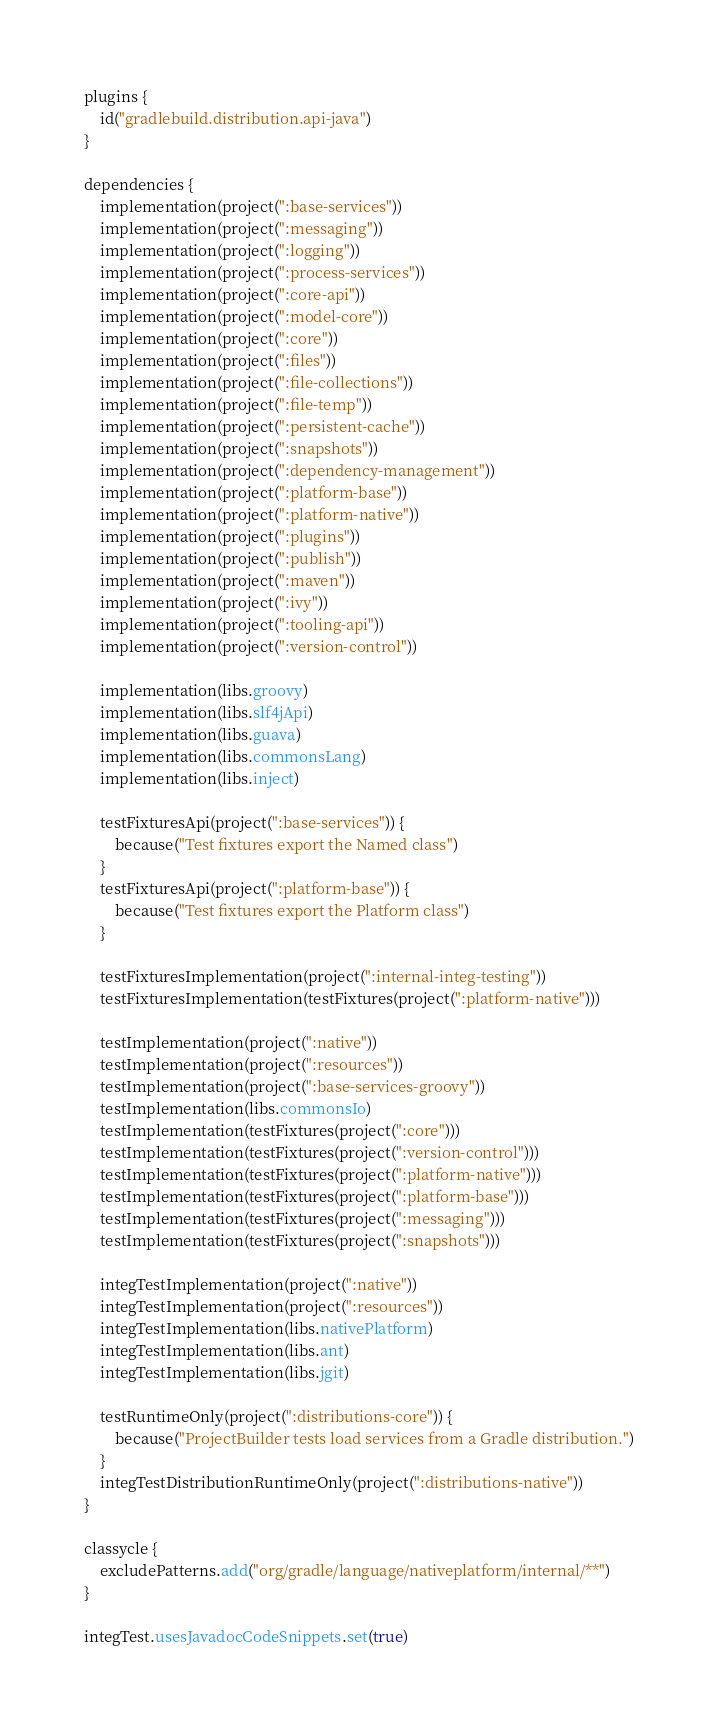<code> <loc_0><loc_0><loc_500><loc_500><_Kotlin_>plugins {
    id("gradlebuild.distribution.api-java")
}

dependencies {
    implementation(project(":base-services"))
    implementation(project(":messaging"))
    implementation(project(":logging"))
    implementation(project(":process-services"))
    implementation(project(":core-api"))
    implementation(project(":model-core"))
    implementation(project(":core"))
    implementation(project(":files"))
    implementation(project(":file-collections"))
    implementation(project(":file-temp"))
    implementation(project(":persistent-cache"))
    implementation(project(":snapshots"))
    implementation(project(":dependency-management"))
    implementation(project(":platform-base"))
    implementation(project(":platform-native"))
    implementation(project(":plugins"))
    implementation(project(":publish"))
    implementation(project(":maven"))
    implementation(project(":ivy"))
    implementation(project(":tooling-api"))
    implementation(project(":version-control"))

    implementation(libs.groovy)
    implementation(libs.slf4jApi)
    implementation(libs.guava)
    implementation(libs.commonsLang)
    implementation(libs.inject)

    testFixturesApi(project(":base-services")) {
        because("Test fixtures export the Named class")
    }
    testFixturesApi(project(":platform-base")) {
        because("Test fixtures export the Platform class")
    }

    testFixturesImplementation(project(":internal-integ-testing"))
    testFixturesImplementation(testFixtures(project(":platform-native")))

    testImplementation(project(":native"))
    testImplementation(project(":resources"))
    testImplementation(project(":base-services-groovy"))
    testImplementation(libs.commonsIo)
    testImplementation(testFixtures(project(":core")))
    testImplementation(testFixtures(project(":version-control")))
    testImplementation(testFixtures(project(":platform-native")))
    testImplementation(testFixtures(project(":platform-base")))
    testImplementation(testFixtures(project(":messaging")))
    testImplementation(testFixtures(project(":snapshots")))

    integTestImplementation(project(":native"))
    integTestImplementation(project(":resources"))
    integTestImplementation(libs.nativePlatform)
    integTestImplementation(libs.ant)
    integTestImplementation(libs.jgit)

    testRuntimeOnly(project(":distributions-core")) {
        because("ProjectBuilder tests load services from a Gradle distribution.")
    }
    integTestDistributionRuntimeOnly(project(":distributions-native"))
}

classycle {
    excludePatterns.add("org/gradle/language/nativeplatform/internal/**")
}

integTest.usesJavadocCodeSnippets.set(true)
</code> 